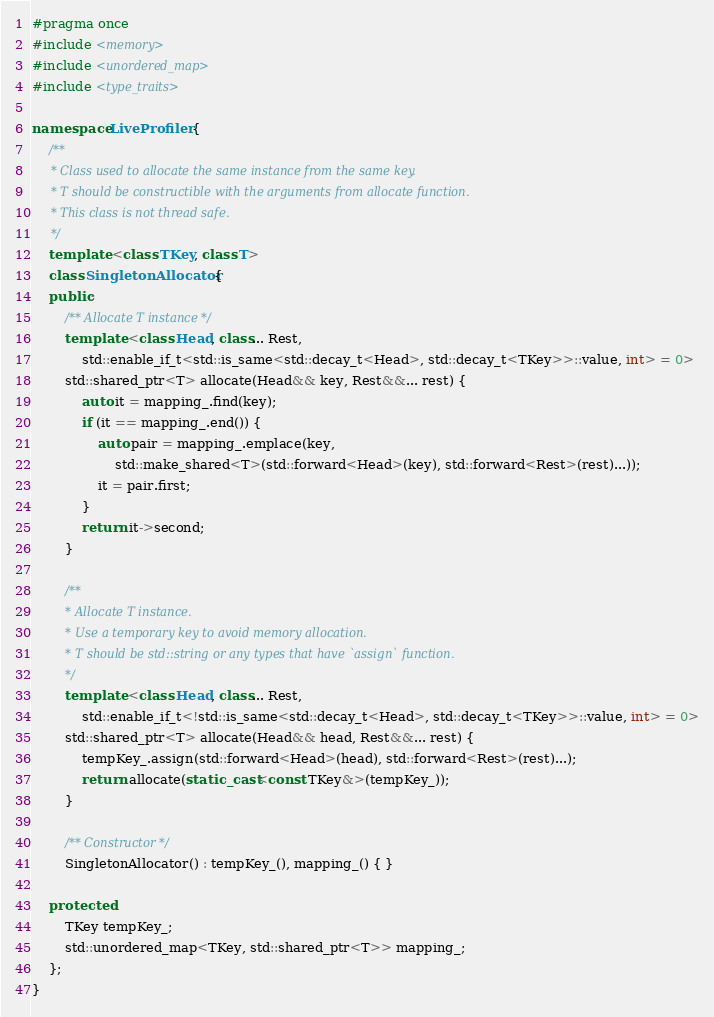Convert code to text. <code><loc_0><loc_0><loc_500><loc_500><_C++_>#pragma once
#include <memory>
#include <unordered_map>
#include <type_traits>

namespace LiveProfiler {
	/**
	 * Class used to allocate the same instance from the same key.
	 * T should be constructible with the arguments from allocate function.
	 * This class is not thread safe.
	 */
	template <class TKey, class T>
	class SingletonAllocator {
	public:
		/** Allocate T instance */
		template <class Head, class... Rest,
			std::enable_if_t<std::is_same<std::decay_t<Head>, std::decay_t<TKey>>::value, int> = 0>
		std::shared_ptr<T> allocate(Head&& key, Rest&&... rest) {
			auto it = mapping_.find(key);
			if (it == mapping_.end()) {
				auto pair = mapping_.emplace(key,
					std::make_shared<T>(std::forward<Head>(key), std::forward<Rest>(rest)...));
				it = pair.first;
			}
			return it->second;
		}

		/**
		 * Allocate T instance.
		 * Use a temporary key to avoid memory allocation.
		 * T should be std::string or any types that have `assign` function.
		 */
		template <class Head, class... Rest,
			std::enable_if_t<!std::is_same<std::decay_t<Head>, std::decay_t<TKey>>::value, int> = 0>
		std::shared_ptr<T> allocate(Head&& head, Rest&&... rest) {
			tempKey_.assign(std::forward<Head>(head), std::forward<Rest>(rest)...);
			return allocate(static_cast<const TKey&>(tempKey_));
		}

		/** Constructor */
		SingletonAllocator() : tempKey_(), mapping_() { }

	protected:
		TKey tempKey_;
		std::unordered_map<TKey, std::shared_ptr<T>> mapping_;
	};
}

</code> 